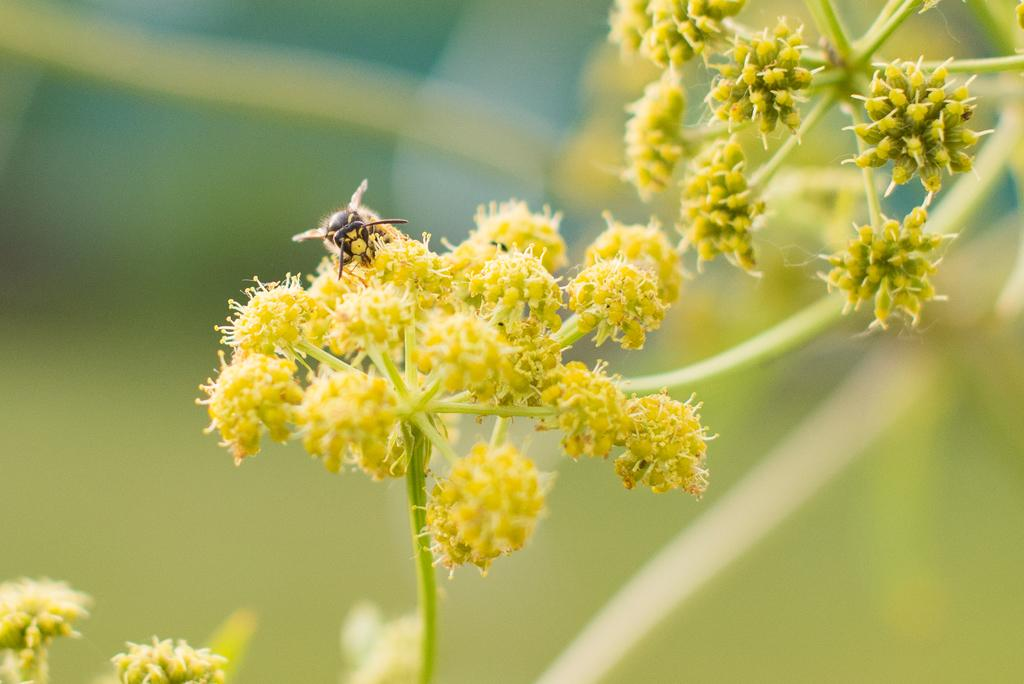What is present in the picture? There are flowers and a honey bee in the picture. Where is the honey bee located in the picture? The honey bee is in the center of the picture. How would you describe the background of the picture? The background of the picture is blurred. What type of food is the honey bee carrying in the picture? There is no food visible in the picture; the honey bee is not carrying anything. 